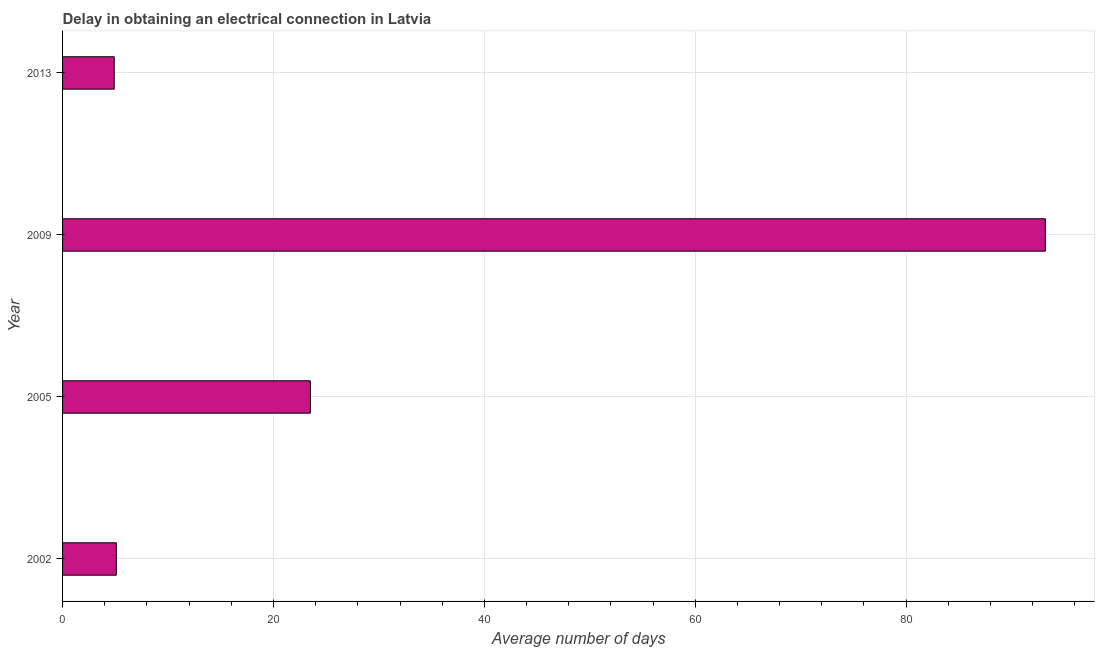Does the graph contain grids?
Make the answer very short. Yes. What is the title of the graph?
Offer a terse response. Delay in obtaining an electrical connection in Latvia. What is the label or title of the X-axis?
Ensure brevity in your answer.  Average number of days. What is the dalay in electrical connection in 2013?
Your answer should be compact. 4.9. Across all years, what is the maximum dalay in electrical connection?
Your answer should be compact. 93.2. Across all years, what is the minimum dalay in electrical connection?
Offer a terse response. 4.9. What is the sum of the dalay in electrical connection?
Give a very brief answer. 126.7. What is the difference between the dalay in electrical connection in 2005 and 2009?
Offer a terse response. -69.7. What is the average dalay in electrical connection per year?
Your response must be concise. 31.68. What is the median dalay in electrical connection?
Offer a very short reply. 14.3. In how many years, is the dalay in electrical connection greater than 4 days?
Offer a terse response. 4. What is the ratio of the dalay in electrical connection in 2009 to that in 2013?
Your answer should be compact. 19.02. Is the difference between the dalay in electrical connection in 2005 and 2013 greater than the difference between any two years?
Keep it short and to the point. No. What is the difference between the highest and the second highest dalay in electrical connection?
Keep it short and to the point. 69.7. Is the sum of the dalay in electrical connection in 2005 and 2013 greater than the maximum dalay in electrical connection across all years?
Give a very brief answer. No. What is the difference between the highest and the lowest dalay in electrical connection?
Make the answer very short. 88.3. How many bars are there?
Your answer should be compact. 4. Are all the bars in the graph horizontal?
Give a very brief answer. Yes. What is the difference between two consecutive major ticks on the X-axis?
Give a very brief answer. 20. What is the Average number of days of 2005?
Make the answer very short. 23.5. What is the Average number of days in 2009?
Give a very brief answer. 93.2. What is the Average number of days of 2013?
Offer a terse response. 4.9. What is the difference between the Average number of days in 2002 and 2005?
Keep it short and to the point. -18.4. What is the difference between the Average number of days in 2002 and 2009?
Give a very brief answer. -88.1. What is the difference between the Average number of days in 2005 and 2009?
Make the answer very short. -69.7. What is the difference between the Average number of days in 2005 and 2013?
Offer a terse response. 18.6. What is the difference between the Average number of days in 2009 and 2013?
Your answer should be very brief. 88.3. What is the ratio of the Average number of days in 2002 to that in 2005?
Ensure brevity in your answer.  0.22. What is the ratio of the Average number of days in 2002 to that in 2009?
Give a very brief answer. 0.06. What is the ratio of the Average number of days in 2002 to that in 2013?
Your response must be concise. 1.04. What is the ratio of the Average number of days in 2005 to that in 2009?
Provide a short and direct response. 0.25. What is the ratio of the Average number of days in 2005 to that in 2013?
Ensure brevity in your answer.  4.8. What is the ratio of the Average number of days in 2009 to that in 2013?
Your response must be concise. 19.02. 